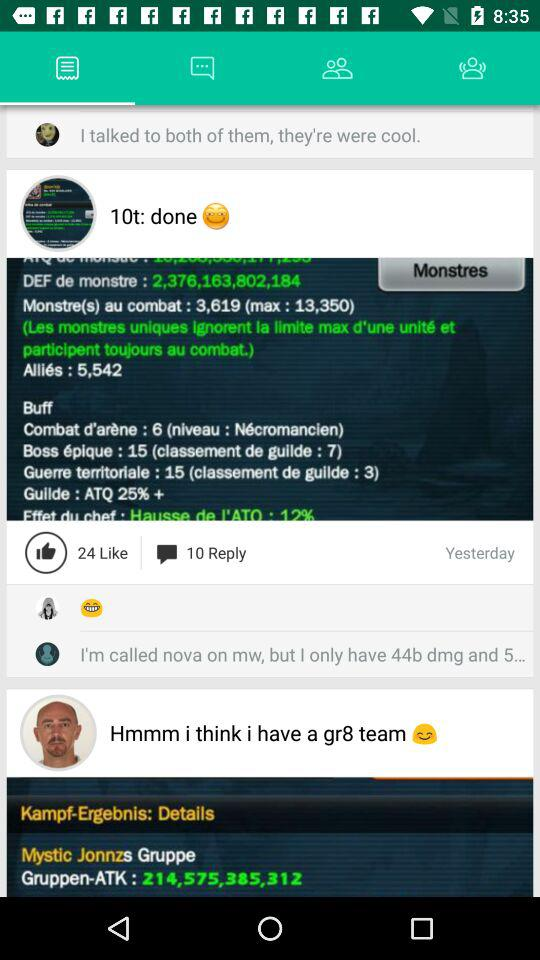What day was the post posted? The day is yesterday. 